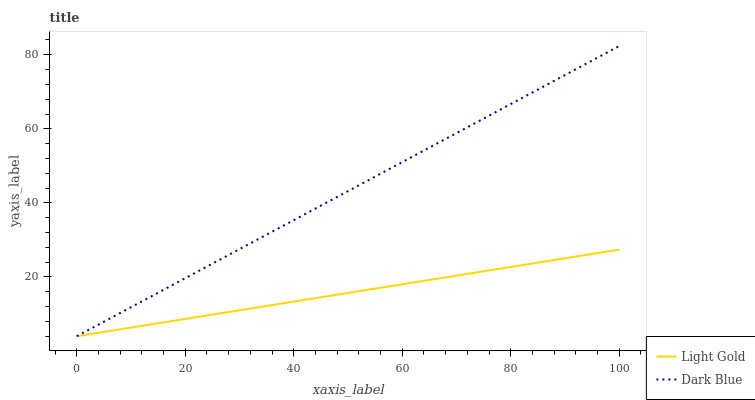Does Light Gold have the minimum area under the curve?
Answer yes or no. Yes. Does Dark Blue have the maximum area under the curve?
Answer yes or no. Yes. Does Light Gold have the maximum area under the curve?
Answer yes or no. No. Is Light Gold the smoothest?
Answer yes or no. Yes. Is Dark Blue the roughest?
Answer yes or no. Yes. Is Light Gold the roughest?
Answer yes or no. No. Does Dark Blue have the lowest value?
Answer yes or no. Yes. Does Dark Blue have the highest value?
Answer yes or no. Yes. Does Light Gold have the highest value?
Answer yes or no. No. Does Light Gold intersect Dark Blue?
Answer yes or no. Yes. Is Light Gold less than Dark Blue?
Answer yes or no. No. Is Light Gold greater than Dark Blue?
Answer yes or no. No. 